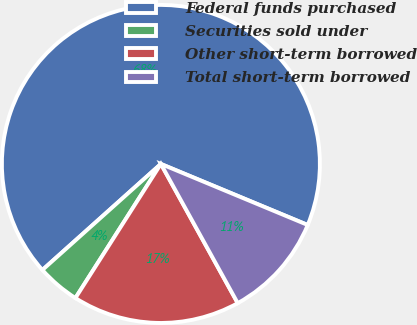Convert chart. <chart><loc_0><loc_0><loc_500><loc_500><pie_chart><fcel>Federal funds purchased<fcel>Securities sold under<fcel>Other short-term borrowed<fcel>Total short-term borrowed<nl><fcel>67.89%<fcel>4.35%<fcel>17.06%<fcel>10.7%<nl></chart> 